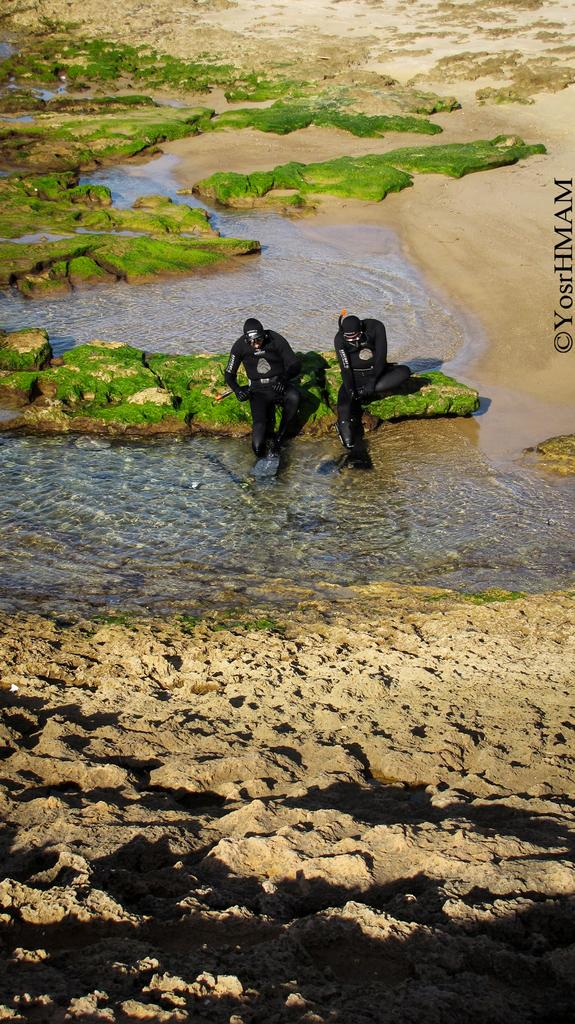How many people are sitting in the image? There are two people sitting in the image. What type of environment is depicted in the image? The image shows a water and sand environment. What type of plant life is present in the image? Algae is present in the image. What is located on the right side of the image? There is text on the right side of the image. What color is the glove being worn by the family in the image? There is no family or glove present in the image. 